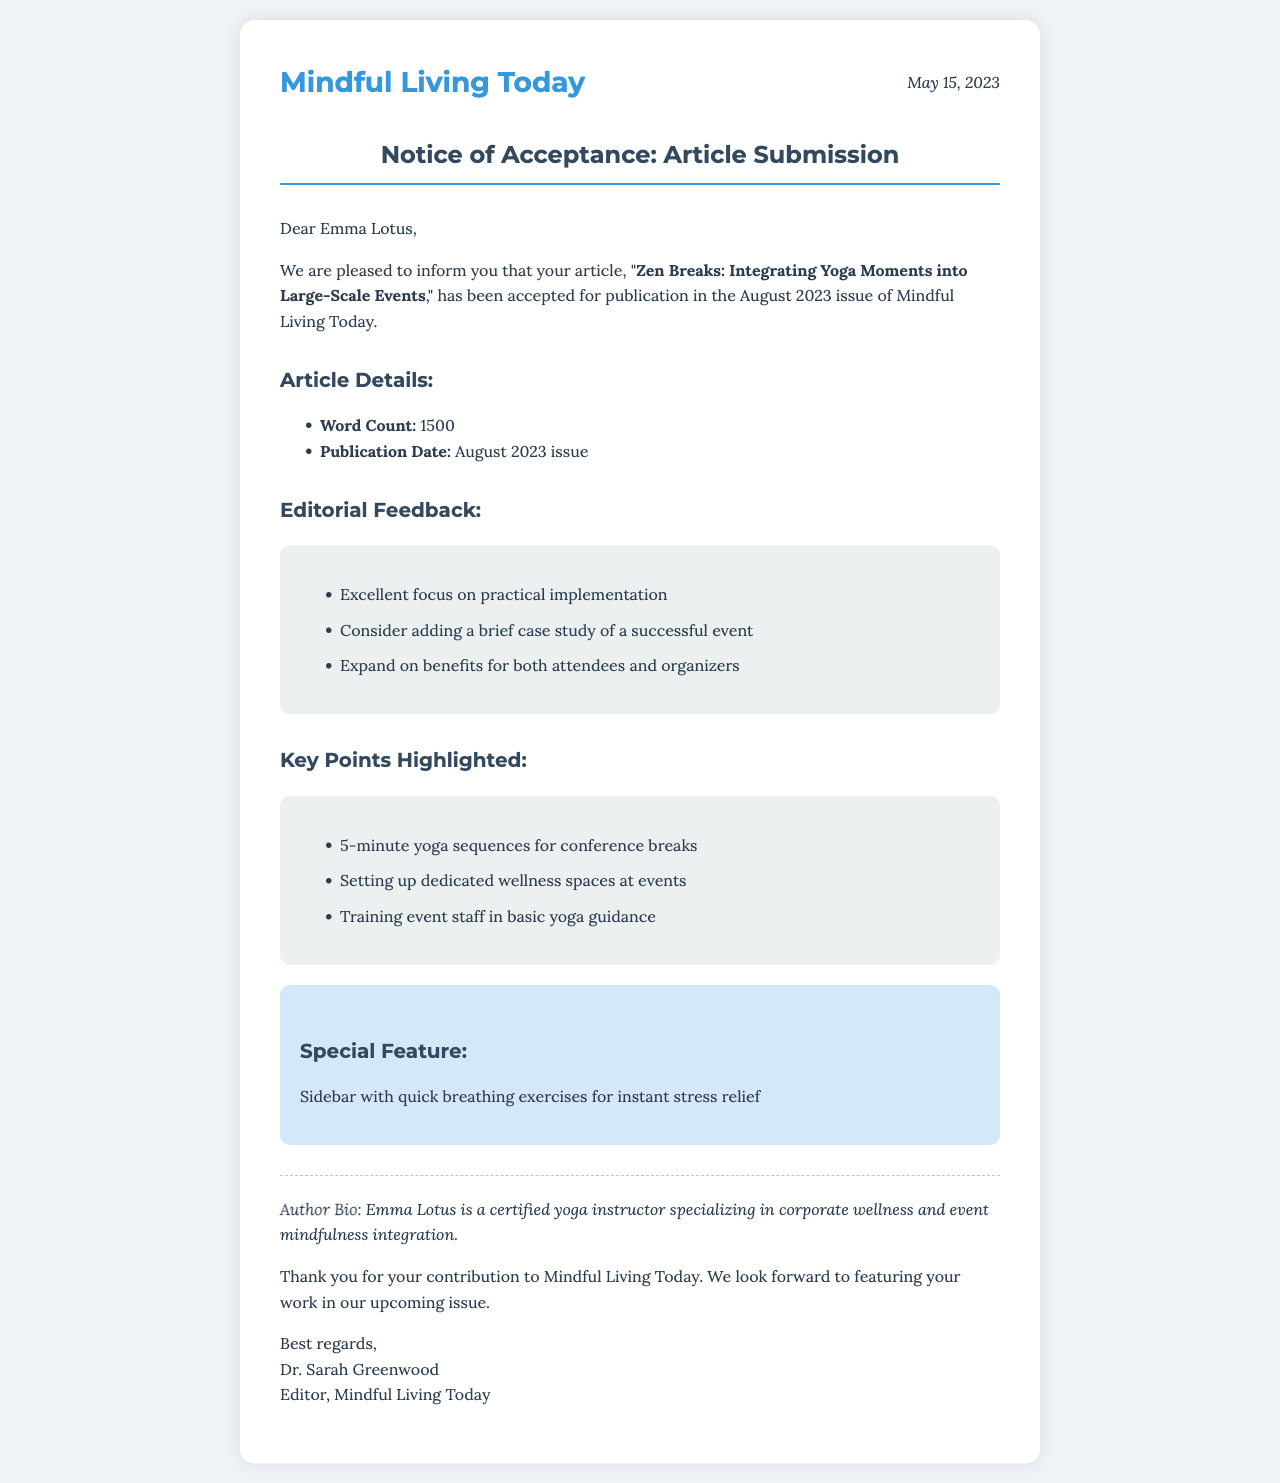What is the title of the accepted article? The title is clearly stated in the first paragraph of the document.
Answer: Zen Breaks: Integrating Yoga Moments into Large-Scale Events What is the word count of the article? The word count is mentioned in the article details section.
Answer: 1500 Who is the editor of Mindful Living Today? The editor's name is provided in the closing signature of the document.
Answer: Dr. Sarah Greenwood What is one piece of editorial feedback given? The feedback section lists several points for improvement mentioned by the editor.
Answer: Excellent focus on practical implementation What is a key point highlighted in the document? The key points section lists important aspects of the article related to yoga breaks.
Answer: 5-minute yoga sequences for conference breaks When will the article be published? The publication date is specified in the article details section.
Answer: August 2023 What is the purpose of the special feature mentioned? The special feature provides additional insights linked to the main article.
Answer: Sidebar with quick breathing exercises for instant stress relief What does the author specialize in? The author bio provides information on the author’s area of expertise.
Answer: Corporate wellness and event mindfulness integration 